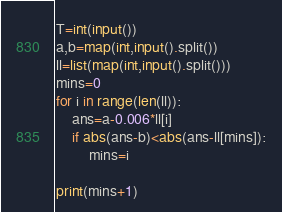<code> <loc_0><loc_0><loc_500><loc_500><_Python_>T=int(input())
a,b=map(int,input().split())
ll=list(map(int,input().split()))
mins=0
for i in range(len(ll)):
    ans=a-0.006*ll[i]
    if abs(ans-b)<abs(ans-ll[mins]):
        mins=i

print(mins+1)</code> 